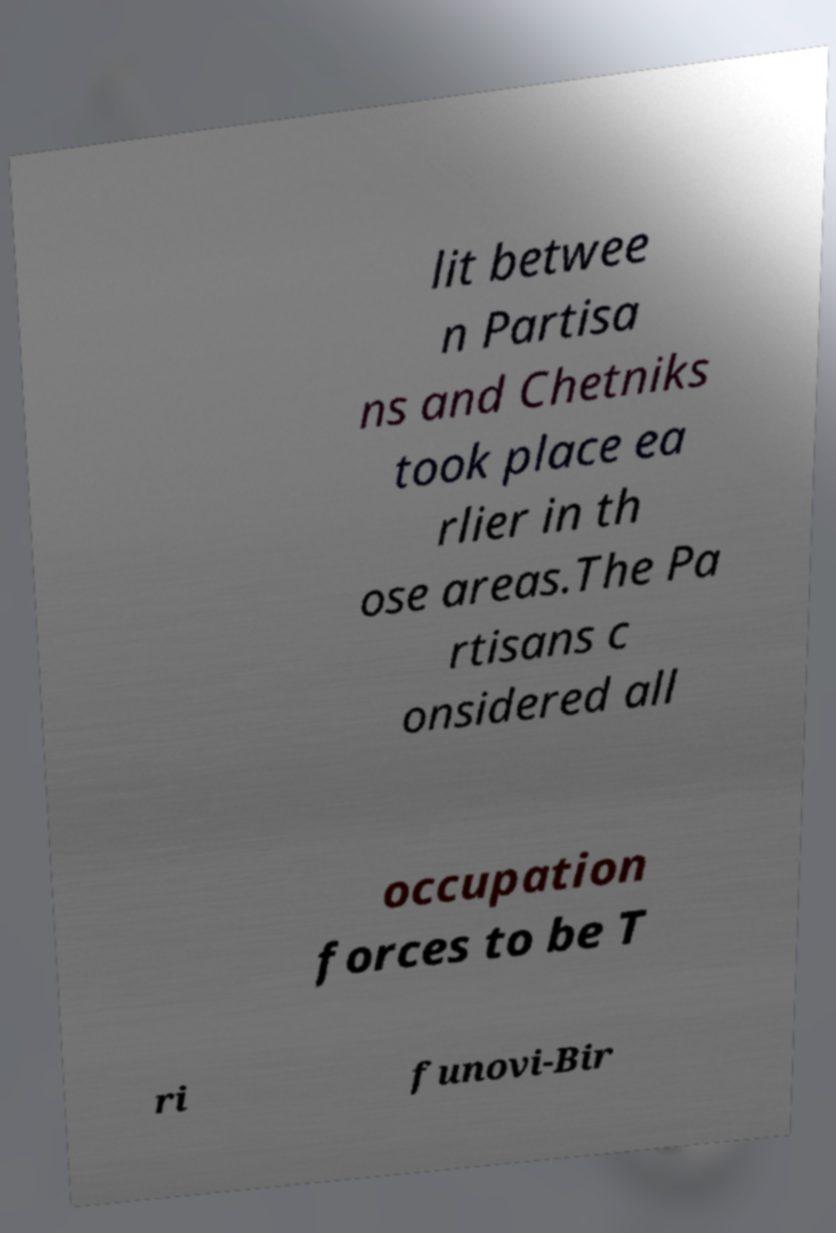Can you read and provide the text displayed in the image?This photo seems to have some interesting text. Can you extract and type it out for me? lit betwee n Partisa ns and Chetniks took place ea rlier in th ose areas.The Pa rtisans c onsidered all occupation forces to be T ri funovi-Bir 